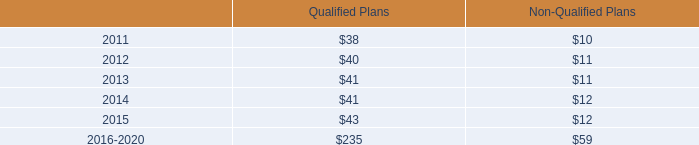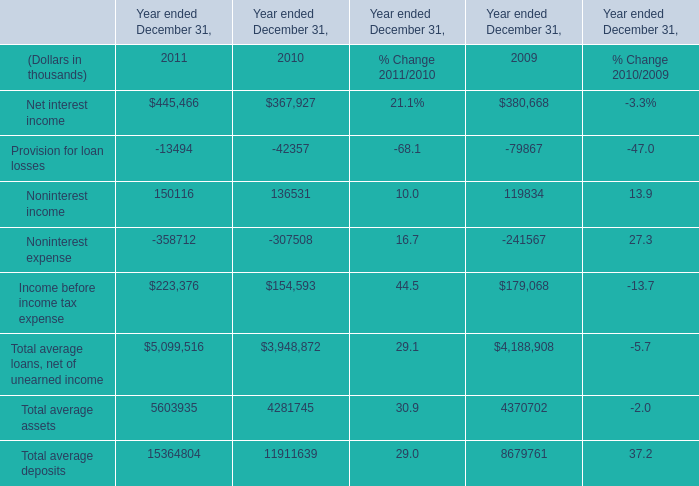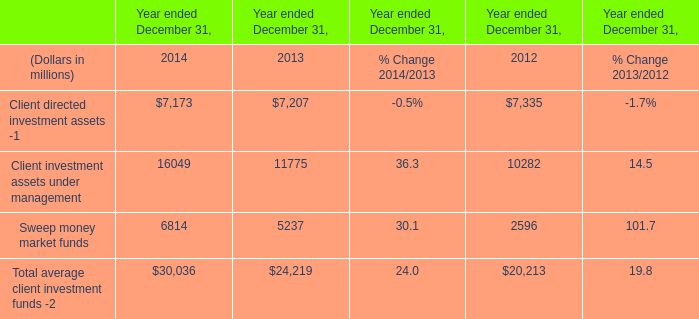What is the sum of Sweep money market funds of Year ended December 31, 2014, and Noninterest expense of Year ended December 31, 2011 ? 
Computations: (6814.0 + 358712.0)
Answer: 365526.0. 